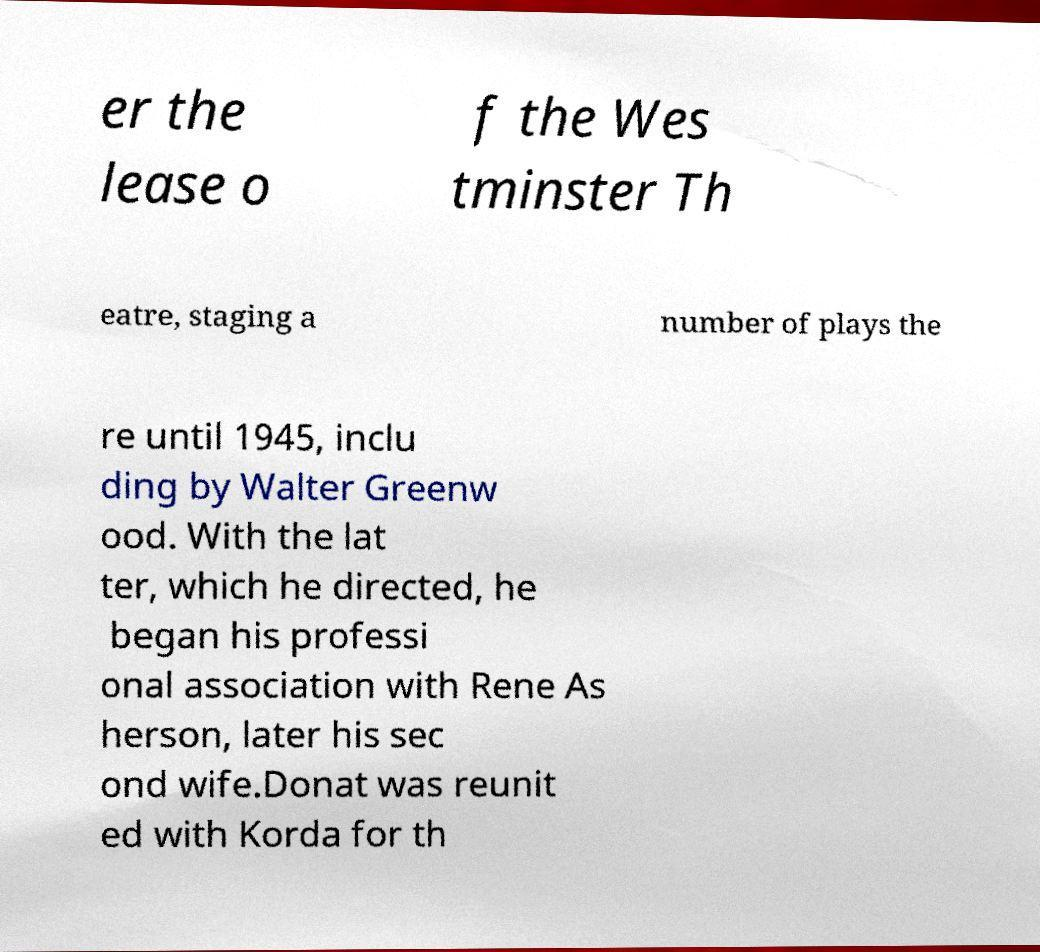Could you assist in decoding the text presented in this image and type it out clearly? er the lease o f the Wes tminster Th eatre, staging a number of plays the re until 1945, inclu ding by Walter Greenw ood. With the lat ter, which he directed, he began his professi onal association with Rene As herson, later his sec ond wife.Donat was reunit ed with Korda for th 